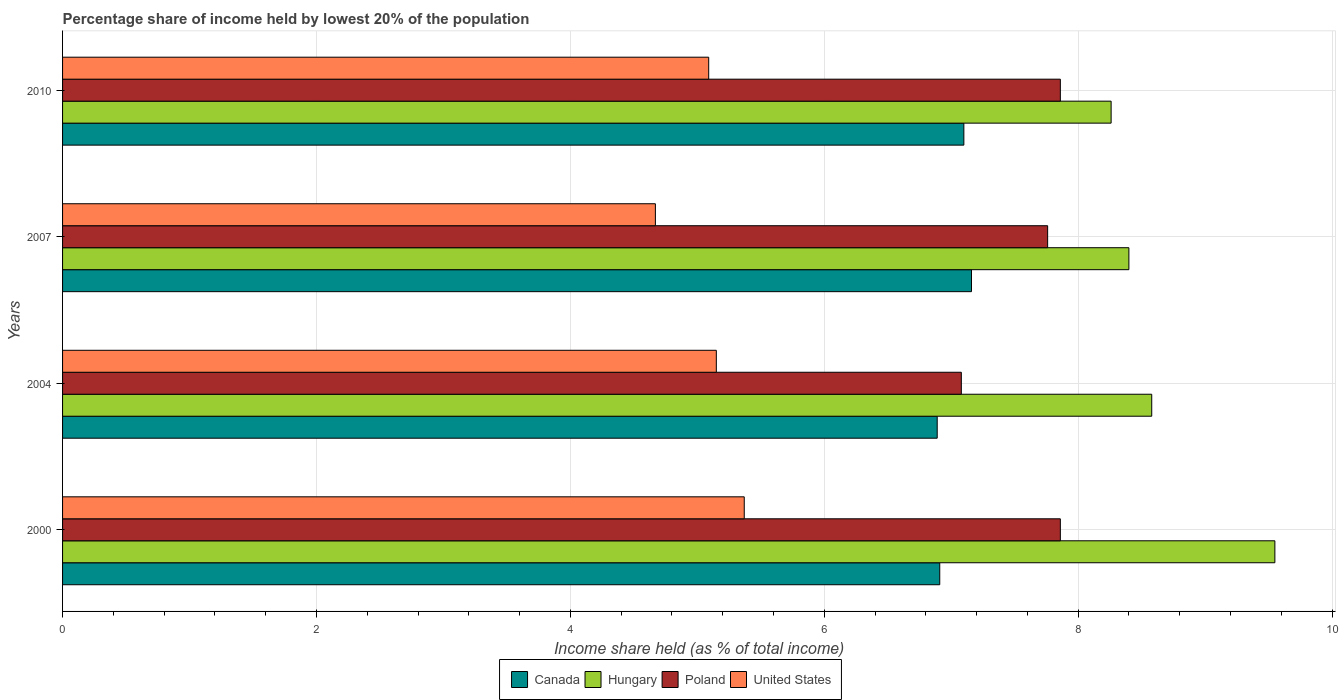Are the number of bars per tick equal to the number of legend labels?
Your response must be concise. Yes. How many bars are there on the 1st tick from the top?
Your answer should be compact. 4. How many bars are there on the 1st tick from the bottom?
Your response must be concise. 4. What is the label of the 1st group of bars from the top?
Make the answer very short. 2010. In how many cases, is the number of bars for a given year not equal to the number of legend labels?
Your response must be concise. 0. What is the percentage share of income held by lowest 20% of the population in Poland in 2004?
Provide a succinct answer. 7.08. Across all years, what is the maximum percentage share of income held by lowest 20% of the population in United States?
Make the answer very short. 5.37. Across all years, what is the minimum percentage share of income held by lowest 20% of the population in Poland?
Your answer should be very brief. 7.08. What is the total percentage share of income held by lowest 20% of the population in United States in the graph?
Your answer should be very brief. 20.28. What is the difference between the percentage share of income held by lowest 20% of the population in Poland in 2000 and that in 2007?
Give a very brief answer. 0.1. What is the difference between the percentage share of income held by lowest 20% of the population in Canada in 2000 and the percentage share of income held by lowest 20% of the population in Poland in 2007?
Ensure brevity in your answer.  -0.85. What is the average percentage share of income held by lowest 20% of the population in Hungary per year?
Make the answer very short. 8.7. In the year 2010, what is the difference between the percentage share of income held by lowest 20% of the population in Poland and percentage share of income held by lowest 20% of the population in Hungary?
Provide a succinct answer. -0.4. In how many years, is the percentage share of income held by lowest 20% of the population in Poland greater than 2 %?
Provide a short and direct response. 4. What is the ratio of the percentage share of income held by lowest 20% of the population in United States in 2000 to that in 2007?
Offer a very short reply. 1.15. Is the percentage share of income held by lowest 20% of the population in Poland in 2000 less than that in 2007?
Give a very brief answer. No. Is the difference between the percentage share of income held by lowest 20% of the population in Poland in 2007 and 2010 greater than the difference between the percentage share of income held by lowest 20% of the population in Hungary in 2007 and 2010?
Offer a terse response. No. What is the difference between the highest and the lowest percentage share of income held by lowest 20% of the population in Canada?
Give a very brief answer. 0.27. Are all the bars in the graph horizontal?
Your response must be concise. Yes. Does the graph contain any zero values?
Your answer should be very brief. No. Does the graph contain grids?
Your response must be concise. Yes. Where does the legend appear in the graph?
Your answer should be compact. Bottom center. How are the legend labels stacked?
Your answer should be very brief. Horizontal. What is the title of the graph?
Provide a succinct answer. Percentage share of income held by lowest 20% of the population. What is the label or title of the X-axis?
Your response must be concise. Income share held (as % of total income). What is the label or title of the Y-axis?
Give a very brief answer. Years. What is the Income share held (as % of total income) of Canada in 2000?
Your response must be concise. 6.91. What is the Income share held (as % of total income) in Hungary in 2000?
Give a very brief answer. 9.55. What is the Income share held (as % of total income) of Poland in 2000?
Ensure brevity in your answer.  7.86. What is the Income share held (as % of total income) of United States in 2000?
Provide a succinct answer. 5.37. What is the Income share held (as % of total income) in Canada in 2004?
Your response must be concise. 6.89. What is the Income share held (as % of total income) of Hungary in 2004?
Ensure brevity in your answer.  8.58. What is the Income share held (as % of total income) in Poland in 2004?
Provide a short and direct response. 7.08. What is the Income share held (as % of total income) of United States in 2004?
Your response must be concise. 5.15. What is the Income share held (as % of total income) of Canada in 2007?
Make the answer very short. 7.16. What is the Income share held (as % of total income) of Poland in 2007?
Give a very brief answer. 7.76. What is the Income share held (as % of total income) in United States in 2007?
Keep it short and to the point. 4.67. What is the Income share held (as % of total income) of Hungary in 2010?
Your answer should be very brief. 8.26. What is the Income share held (as % of total income) in Poland in 2010?
Provide a short and direct response. 7.86. What is the Income share held (as % of total income) of United States in 2010?
Provide a short and direct response. 5.09. Across all years, what is the maximum Income share held (as % of total income) of Canada?
Make the answer very short. 7.16. Across all years, what is the maximum Income share held (as % of total income) of Hungary?
Your answer should be very brief. 9.55. Across all years, what is the maximum Income share held (as % of total income) in Poland?
Offer a very short reply. 7.86. Across all years, what is the maximum Income share held (as % of total income) of United States?
Provide a short and direct response. 5.37. Across all years, what is the minimum Income share held (as % of total income) in Canada?
Your response must be concise. 6.89. Across all years, what is the minimum Income share held (as % of total income) of Hungary?
Offer a very short reply. 8.26. Across all years, what is the minimum Income share held (as % of total income) in Poland?
Offer a very short reply. 7.08. Across all years, what is the minimum Income share held (as % of total income) in United States?
Your response must be concise. 4.67. What is the total Income share held (as % of total income) in Canada in the graph?
Your answer should be compact. 28.06. What is the total Income share held (as % of total income) of Hungary in the graph?
Provide a succinct answer. 34.79. What is the total Income share held (as % of total income) of Poland in the graph?
Your answer should be compact. 30.56. What is the total Income share held (as % of total income) of United States in the graph?
Ensure brevity in your answer.  20.28. What is the difference between the Income share held (as % of total income) in Canada in 2000 and that in 2004?
Give a very brief answer. 0.02. What is the difference between the Income share held (as % of total income) in Hungary in 2000 and that in 2004?
Offer a very short reply. 0.97. What is the difference between the Income share held (as % of total income) of Poland in 2000 and that in 2004?
Keep it short and to the point. 0.78. What is the difference between the Income share held (as % of total income) in United States in 2000 and that in 2004?
Offer a very short reply. 0.22. What is the difference between the Income share held (as % of total income) in Hungary in 2000 and that in 2007?
Provide a short and direct response. 1.15. What is the difference between the Income share held (as % of total income) of Canada in 2000 and that in 2010?
Give a very brief answer. -0.19. What is the difference between the Income share held (as % of total income) in Hungary in 2000 and that in 2010?
Your response must be concise. 1.29. What is the difference between the Income share held (as % of total income) of Poland in 2000 and that in 2010?
Ensure brevity in your answer.  0. What is the difference between the Income share held (as % of total income) in United States in 2000 and that in 2010?
Ensure brevity in your answer.  0.28. What is the difference between the Income share held (as % of total income) in Canada in 2004 and that in 2007?
Give a very brief answer. -0.27. What is the difference between the Income share held (as % of total income) of Hungary in 2004 and that in 2007?
Keep it short and to the point. 0.18. What is the difference between the Income share held (as % of total income) of Poland in 2004 and that in 2007?
Provide a succinct answer. -0.68. What is the difference between the Income share held (as % of total income) in United States in 2004 and that in 2007?
Keep it short and to the point. 0.48. What is the difference between the Income share held (as % of total income) in Canada in 2004 and that in 2010?
Ensure brevity in your answer.  -0.21. What is the difference between the Income share held (as % of total income) of Hungary in 2004 and that in 2010?
Keep it short and to the point. 0.32. What is the difference between the Income share held (as % of total income) in Poland in 2004 and that in 2010?
Your answer should be compact. -0.78. What is the difference between the Income share held (as % of total income) of Canada in 2007 and that in 2010?
Make the answer very short. 0.06. What is the difference between the Income share held (as % of total income) in Hungary in 2007 and that in 2010?
Provide a succinct answer. 0.14. What is the difference between the Income share held (as % of total income) in United States in 2007 and that in 2010?
Your response must be concise. -0.42. What is the difference between the Income share held (as % of total income) in Canada in 2000 and the Income share held (as % of total income) in Hungary in 2004?
Your answer should be compact. -1.67. What is the difference between the Income share held (as % of total income) in Canada in 2000 and the Income share held (as % of total income) in Poland in 2004?
Offer a terse response. -0.17. What is the difference between the Income share held (as % of total income) of Canada in 2000 and the Income share held (as % of total income) of United States in 2004?
Offer a very short reply. 1.76. What is the difference between the Income share held (as % of total income) of Hungary in 2000 and the Income share held (as % of total income) of Poland in 2004?
Your response must be concise. 2.47. What is the difference between the Income share held (as % of total income) of Poland in 2000 and the Income share held (as % of total income) of United States in 2004?
Your answer should be very brief. 2.71. What is the difference between the Income share held (as % of total income) of Canada in 2000 and the Income share held (as % of total income) of Hungary in 2007?
Keep it short and to the point. -1.49. What is the difference between the Income share held (as % of total income) of Canada in 2000 and the Income share held (as % of total income) of Poland in 2007?
Offer a terse response. -0.85. What is the difference between the Income share held (as % of total income) of Canada in 2000 and the Income share held (as % of total income) of United States in 2007?
Keep it short and to the point. 2.24. What is the difference between the Income share held (as % of total income) in Hungary in 2000 and the Income share held (as % of total income) in Poland in 2007?
Offer a very short reply. 1.79. What is the difference between the Income share held (as % of total income) in Hungary in 2000 and the Income share held (as % of total income) in United States in 2007?
Keep it short and to the point. 4.88. What is the difference between the Income share held (as % of total income) of Poland in 2000 and the Income share held (as % of total income) of United States in 2007?
Give a very brief answer. 3.19. What is the difference between the Income share held (as % of total income) in Canada in 2000 and the Income share held (as % of total income) in Hungary in 2010?
Your answer should be compact. -1.35. What is the difference between the Income share held (as % of total income) in Canada in 2000 and the Income share held (as % of total income) in Poland in 2010?
Your answer should be very brief. -0.95. What is the difference between the Income share held (as % of total income) of Canada in 2000 and the Income share held (as % of total income) of United States in 2010?
Give a very brief answer. 1.82. What is the difference between the Income share held (as % of total income) of Hungary in 2000 and the Income share held (as % of total income) of Poland in 2010?
Ensure brevity in your answer.  1.69. What is the difference between the Income share held (as % of total income) of Hungary in 2000 and the Income share held (as % of total income) of United States in 2010?
Ensure brevity in your answer.  4.46. What is the difference between the Income share held (as % of total income) of Poland in 2000 and the Income share held (as % of total income) of United States in 2010?
Ensure brevity in your answer.  2.77. What is the difference between the Income share held (as % of total income) in Canada in 2004 and the Income share held (as % of total income) in Hungary in 2007?
Keep it short and to the point. -1.51. What is the difference between the Income share held (as % of total income) in Canada in 2004 and the Income share held (as % of total income) in Poland in 2007?
Keep it short and to the point. -0.87. What is the difference between the Income share held (as % of total income) in Canada in 2004 and the Income share held (as % of total income) in United States in 2007?
Your answer should be compact. 2.22. What is the difference between the Income share held (as % of total income) of Hungary in 2004 and the Income share held (as % of total income) of Poland in 2007?
Your answer should be compact. 0.82. What is the difference between the Income share held (as % of total income) of Hungary in 2004 and the Income share held (as % of total income) of United States in 2007?
Ensure brevity in your answer.  3.91. What is the difference between the Income share held (as % of total income) of Poland in 2004 and the Income share held (as % of total income) of United States in 2007?
Your answer should be compact. 2.41. What is the difference between the Income share held (as % of total income) in Canada in 2004 and the Income share held (as % of total income) in Hungary in 2010?
Your answer should be compact. -1.37. What is the difference between the Income share held (as % of total income) in Canada in 2004 and the Income share held (as % of total income) in Poland in 2010?
Your response must be concise. -0.97. What is the difference between the Income share held (as % of total income) of Canada in 2004 and the Income share held (as % of total income) of United States in 2010?
Make the answer very short. 1.8. What is the difference between the Income share held (as % of total income) of Hungary in 2004 and the Income share held (as % of total income) of Poland in 2010?
Give a very brief answer. 0.72. What is the difference between the Income share held (as % of total income) in Hungary in 2004 and the Income share held (as % of total income) in United States in 2010?
Keep it short and to the point. 3.49. What is the difference between the Income share held (as % of total income) in Poland in 2004 and the Income share held (as % of total income) in United States in 2010?
Make the answer very short. 1.99. What is the difference between the Income share held (as % of total income) in Canada in 2007 and the Income share held (as % of total income) in Hungary in 2010?
Offer a very short reply. -1.1. What is the difference between the Income share held (as % of total income) in Canada in 2007 and the Income share held (as % of total income) in United States in 2010?
Offer a very short reply. 2.07. What is the difference between the Income share held (as % of total income) in Hungary in 2007 and the Income share held (as % of total income) in Poland in 2010?
Offer a terse response. 0.54. What is the difference between the Income share held (as % of total income) in Hungary in 2007 and the Income share held (as % of total income) in United States in 2010?
Provide a succinct answer. 3.31. What is the difference between the Income share held (as % of total income) in Poland in 2007 and the Income share held (as % of total income) in United States in 2010?
Make the answer very short. 2.67. What is the average Income share held (as % of total income) in Canada per year?
Keep it short and to the point. 7.01. What is the average Income share held (as % of total income) in Hungary per year?
Ensure brevity in your answer.  8.7. What is the average Income share held (as % of total income) of Poland per year?
Offer a terse response. 7.64. What is the average Income share held (as % of total income) in United States per year?
Your answer should be compact. 5.07. In the year 2000, what is the difference between the Income share held (as % of total income) in Canada and Income share held (as % of total income) in Hungary?
Offer a very short reply. -2.64. In the year 2000, what is the difference between the Income share held (as % of total income) of Canada and Income share held (as % of total income) of Poland?
Your answer should be very brief. -0.95. In the year 2000, what is the difference between the Income share held (as % of total income) in Canada and Income share held (as % of total income) in United States?
Offer a very short reply. 1.54. In the year 2000, what is the difference between the Income share held (as % of total income) in Hungary and Income share held (as % of total income) in Poland?
Provide a succinct answer. 1.69. In the year 2000, what is the difference between the Income share held (as % of total income) in Hungary and Income share held (as % of total income) in United States?
Your answer should be very brief. 4.18. In the year 2000, what is the difference between the Income share held (as % of total income) in Poland and Income share held (as % of total income) in United States?
Your response must be concise. 2.49. In the year 2004, what is the difference between the Income share held (as % of total income) in Canada and Income share held (as % of total income) in Hungary?
Offer a terse response. -1.69. In the year 2004, what is the difference between the Income share held (as % of total income) in Canada and Income share held (as % of total income) in Poland?
Offer a very short reply. -0.19. In the year 2004, what is the difference between the Income share held (as % of total income) of Canada and Income share held (as % of total income) of United States?
Offer a terse response. 1.74. In the year 2004, what is the difference between the Income share held (as % of total income) in Hungary and Income share held (as % of total income) in Poland?
Ensure brevity in your answer.  1.5. In the year 2004, what is the difference between the Income share held (as % of total income) in Hungary and Income share held (as % of total income) in United States?
Provide a short and direct response. 3.43. In the year 2004, what is the difference between the Income share held (as % of total income) of Poland and Income share held (as % of total income) of United States?
Provide a short and direct response. 1.93. In the year 2007, what is the difference between the Income share held (as % of total income) of Canada and Income share held (as % of total income) of Hungary?
Keep it short and to the point. -1.24. In the year 2007, what is the difference between the Income share held (as % of total income) in Canada and Income share held (as % of total income) in United States?
Offer a terse response. 2.49. In the year 2007, what is the difference between the Income share held (as % of total income) of Hungary and Income share held (as % of total income) of Poland?
Keep it short and to the point. 0.64. In the year 2007, what is the difference between the Income share held (as % of total income) of Hungary and Income share held (as % of total income) of United States?
Keep it short and to the point. 3.73. In the year 2007, what is the difference between the Income share held (as % of total income) of Poland and Income share held (as % of total income) of United States?
Offer a terse response. 3.09. In the year 2010, what is the difference between the Income share held (as % of total income) of Canada and Income share held (as % of total income) of Hungary?
Offer a terse response. -1.16. In the year 2010, what is the difference between the Income share held (as % of total income) of Canada and Income share held (as % of total income) of Poland?
Offer a terse response. -0.76. In the year 2010, what is the difference between the Income share held (as % of total income) of Canada and Income share held (as % of total income) of United States?
Offer a terse response. 2.01. In the year 2010, what is the difference between the Income share held (as % of total income) in Hungary and Income share held (as % of total income) in Poland?
Give a very brief answer. 0.4. In the year 2010, what is the difference between the Income share held (as % of total income) of Hungary and Income share held (as % of total income) of United States?
Your answer should be compact. 3.17. In the year 2010, what is the difference between the Income share held (as % of total income) of Poland and Income share held (as % of total income) of United States?
Provide a succinct answer. 2.77. What is the ratio of the Income share held (as % of total income) in Hungary in 2000 to that in 2004?
Ensure brevity in your answer.  1.11. What is the ratio of the Income share held (as % of total income) of Poland in 2000 to that in 2004?
Keep it short and to the point. 1.11. What is the ratio of the Income share held (as % of total income) in United States in 2000 to that in 2004?
Ensure brevity in your answer.  1.04. What is the ratio of the Income share held (as % of total income) of Canada in 2000 to that in 2007?
Ensure brevity in your answer.  0.97. What is the ratio of the Income share held (as % of total income) in Hungary in 2000 to that in 2007?
Provide a succinct answer. 1.14. What is the ratio of the Income share held (as % of total income) in Poland in 2000 to that in 2007?
Provide a short and direct response. 1.01. What is the ratio of the Income share held (as % of total income) in United States in 2000 to that in 2007?
Your answer should be compact. 1.15. What is the ratio of the Income share held (as % of total income) in Canada in 2000 to that in 2010?
Ensure brevity in your answer.  0.97. What is the ratio of the Income share held (as % of total income) of Hungary in 2000 to that in 2010?
Offer a very short reply. 1.16. What is the ratio of the Income share held (as % of total income) in United States in 2000 to that in 2010?
Offer a terse response. 1.05. What is the ratio of the Income share held (as % of total income) of Canada in 2004 to that in 2007?
Your answer should be very brief. 0.96. What is the ratio of the Income share held (as % of total income) in Hungary in 2004 to that in 2007?
Keep it short and to the point. 1.02. What is the ratio of the Income share held (as % of total income) of Poland in 2004 to that in 2007?
Your response must be concise. 0.91. What is the ratio of the Income share held (as % of total income) of United States in 2004 to that in 2007?
Your answer should be compact. 1.1. What is the ratio of the Income share held (as % of total income) in Canada in 2004 to that in 2010?
Offer a terse response. 0.97. What is the ratio of the Income share held (as % of total income) of Hungary in 2004 to that in 2010?
Offer a terse response. 1.04. What is the ratio of the Income share held (as % of total income) of Poland in 2004 to that in 2010?
Ensure brevity in your answer.  0.9. What is the ratio of the Income share held (as % of total income) in United States in 2004 to that in 2010?
Make the answer very short. 1.01. What is the ratio of the Income share held (as % of total income) of Canada in 2007 to that in 2010?
Offer a very short reply. 1.01. What is the ratio of the Income share held (as % of total income) of Hungary in 2007 to that in 2010?
Your response must be concise. 1.02. What is the ratio of the Income share held (as % of total income) of Poland in 2007 to that in 2010?
Your answer should be very brief. 0.99. What is the ratio of the Income share held (as % of total income) of United States in 2007 to that in 2010?
Keep it short and to the point. 0.92. What is the difference between the highest and the second highest Income share held (as % of total income) in Hungary?
Offer a very short reply. 0.97. What is the difference between the highest and the second highest Income share held (as % of total income) of Poland?
Your response must be concise. 0. What is the difference between the highest and the second highest Income share held (as % of total income) of United States?
Keep it short and to the point. 0.22. What is the difference between the highest and the lowest Income share held (as % of total income) of Canada?
Provide a succinct answer. 0.27. What is the difference between the highest and the lowest Income share held (as % of total income) of Hungary?
Your answer should be very brief. 1.29. What is the difference between the highest and the lowest Income share held (as % of total income) of Poland?
Your response must be concise. 0.78. What is the difference between the highest and the lowest Income share held (as % of total income) in United States?
Ensure brevity in your answer.  0.7. 